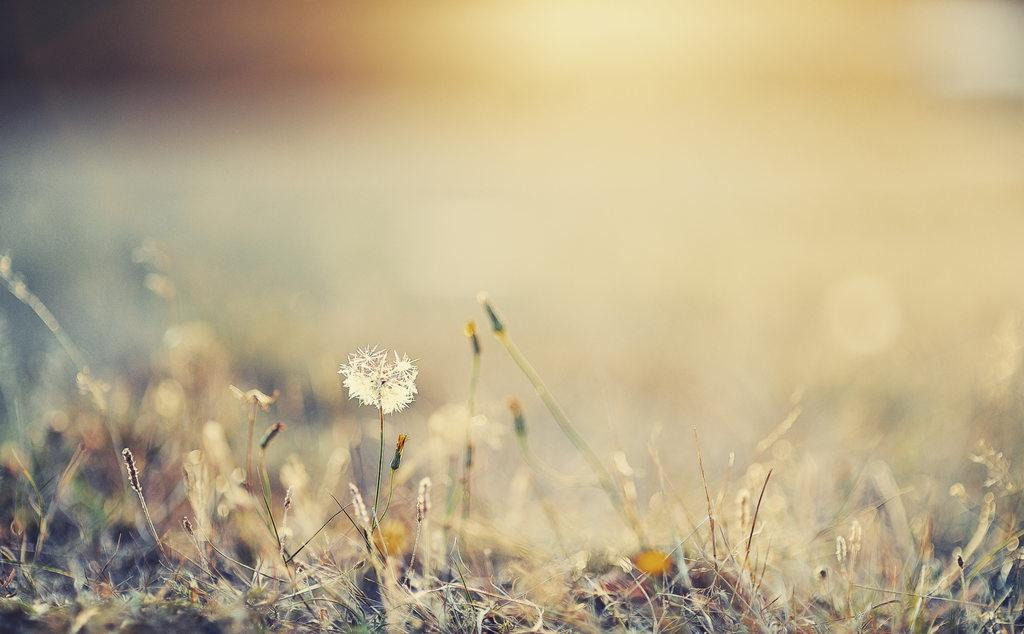What types of living organisms can be seen in the image? Plants and flowers are visible in the image. Can you describe the background of the image? The background of the image is blurred. What type of leg can be seen in the image? There is no leg present in the image; it features plants and flowers. What type of food is being served in the image? There is no food present in the image; it features plants and flowers. 